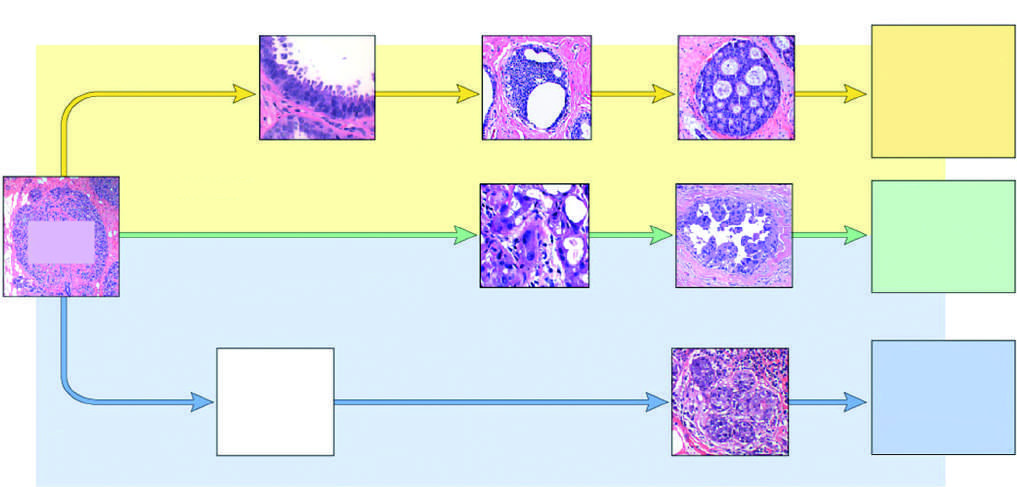what is atypical apocrine adenosis, which shares features with apocrine dcis?
Answer the question using a single word or phrase. A possible precursor lesion 